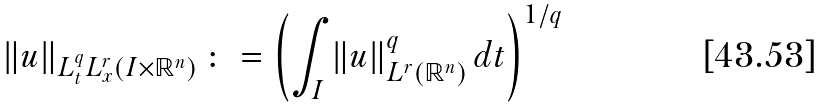Convert formula to latex. <formula><loc_0><loc_0><loc_500><loc_500>\left \| u \right \| _ { L ^ { q } _ { t } L ^ { r } _ { x } ( I \times \mathbb { R } ^ { n } ) } \colon = \left ( \int _ { I } \left \| u \right \| ^ { q } _ { L ^ { r } ( \mathbb { R } ^ { n } ) } d t \right ) ^ { 1 / q }</formula> 